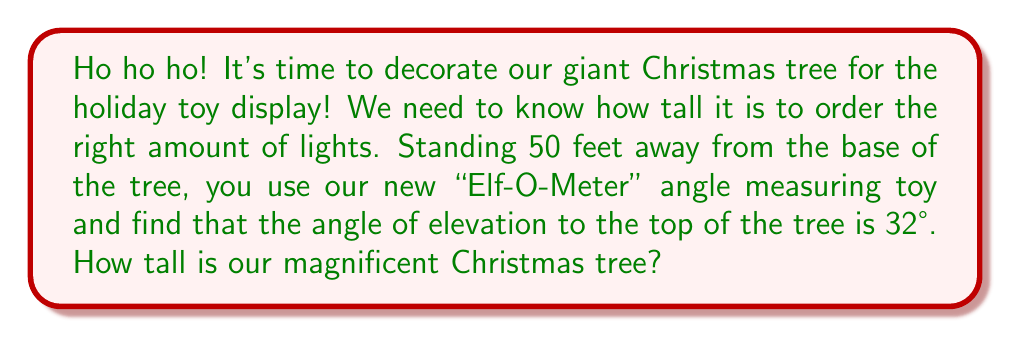Can you answer this question? Let's solve this festive problem step by step:

1) First, let's visualize the scenario:

[asy]
import geometry;

size(200);

pair A = (0,0);
pair B = (5,0);
pair C = (5,3.12);

draw(A--B--C--A);

label("50 ft", (2.5,0), S);
label("Tree height", (5,1.56), E);
label("32°", (0.3,0.1), NW);

dot("A", A, SW);
dot("B", B, SE);
dot("C", C, NE);
[/asy]

2) We can see that this forms a right triangle, where:
   - The adjacent side is the distance from us to the tree (50 feet)
   - The opposite side is the height of the tree (what we're trying to find)
   - The angle of elevation is 32°

3) In this case, we need to use the tangent ratio. Recall that:

   $$\tan \theta = \frac{\text{opposite}}{\text{adjacent}}$$

4) Let's call the height of the tree $h$. We can write:

   $$\tan 32° = \frac{h}{50}$$

5) To solve for $h$, we multiply both sides by 50:

   $$50 \tan 32° = h$$

6) Now we can calculate:
   
   $$h = 50 \times \tan 32° \approx 50 \times 0.6249 \approx 31.24 \text{ feet}$$

7) Rounding to the nearest foot for practical purposes:

   $$h \approx 31 \text{ feet}$$
Answer: The Christmas tree is approximately 31 feet tall. 